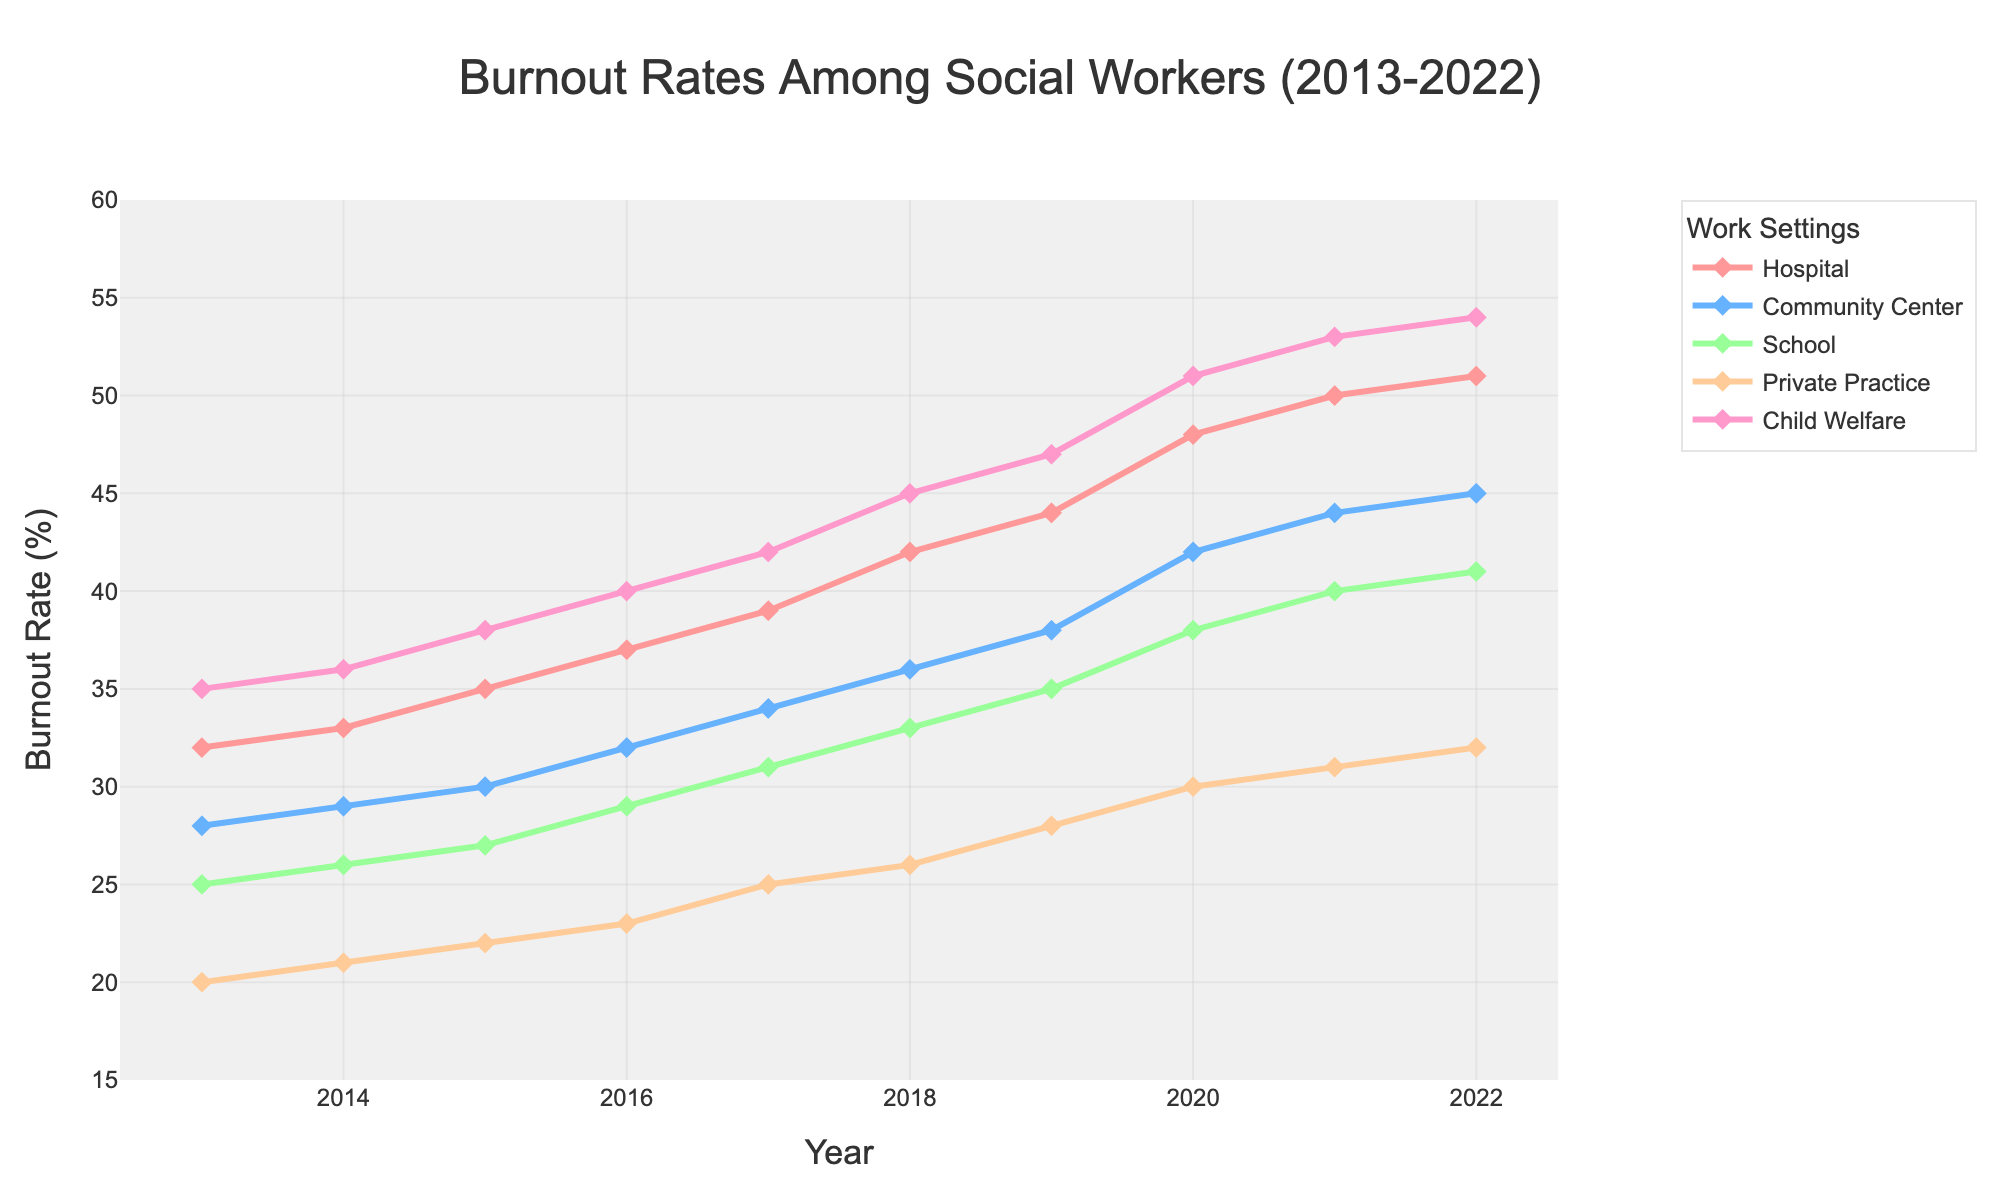What is the burnout rate for social workers in hospitals in 2013? Locate the line representing hospital settings, then find the data point for the year 2013. The corresponding burnout rate is 32%.
Answer: 32% Which work setting has the highest burnout rate in 2022? Compare the data points for all work settings in the year 2022. Child Welfare has the highest at 54%.
Answer: Child Welfare Between Community Center and School settings, which one had a higher burnout rate in 2016? Locate the lines representing Community Center and School settings, then compare the data points for the year 2016. Community Center has a higher burnout rate at 32% compared to 29% for School.
Answer: Community Center What is the overall trend in burnout rates for Private Practice over the decade? Observe the line representing Private Practice from 2013 to 2022. It shows a consistent increase over the years.
Answer: Increasing How much did the burnout rate change for Child Welfare from 2013 to 2022? Subtract the burnout rate for Child Welfare in 2013 from the rate in 2022 (54% - 35%). The change is 19%.
Answer: 19% In which year did Hospital settings experience the largest year-over-year increase in burnout rates? Calculate the year-over-year increases for Hospital settings and find the largest one. From 2019 to 2020, the increase was 4% (48% - 44%).
Answer: 2020 What is the average burnout rate for Schools over the decade? Sum the burnout rates for Schools from 2013 to 2022 (25+26+27+29+31+33+35+38+40+41) and divide by 10. The average rate is 32.5%.
Answer: 32.5% Is the burnout rate in Community Centers in 2018 greater than the burnout rate in Hospitals in 2014? Compare the burnout rate for Community Centers in 2018 (36%) to Hospitals in 2014 (33%). Yes, 36% is greater than 33%.
Answer: Yes Which color represents the Private Practice work setting? Identify the color used for the line representing Private Practice in the chart which is light orange.
Answer: Light Orange 